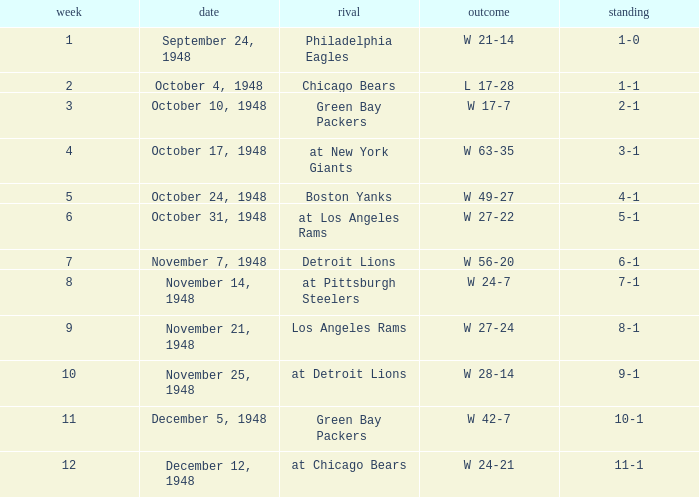What date was the opponent the Boston Yanks? October 24, 1948. 